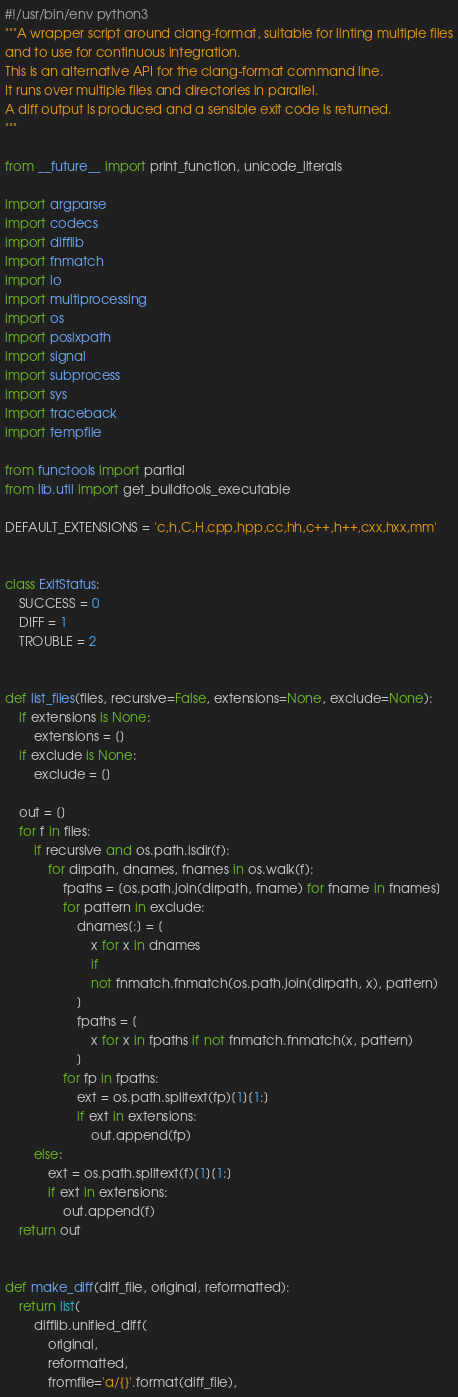Convert code to text. <code><loc_0><loc_0><loc_500><loc_500><_Python_>#!/usr/bin/env python3
"""A wrapper script around clang-format, suitable for linting multiple files
and to use for continuous integration.
This is an alternative API for the clang-format command line.
It runs over multiple files and directories in parallel.
A diff output is produced and a sensible exit code is returned.
"""

from __future__ import print_function, unicode_literals

import argparse
import codecs
import difflib
import fnmatch
import io
import multiprocessing
import os
import posixpath
import signal
import subprocess
import sys
import traceback
import tempfile

from functools import partial
from lib.util import get_buildtools_executable

DEFAULT_EXTENSIONS = 'c,h,C,H,cpp,hpp,cc,hh,c++,h++,cxx,hxx,mm'


class ExitStatus:
    SUCCESS = 0
    DIFF = 1
    TROUBLE = 2


def list_files(files, recursive=False, extensions=None, exclude=None):
    if extensions is None:
        extensions = []
    if exclude is None:
        exclude = []

    out = []
    for f in files:
        if recursive and os.path.isdir(f):
            for dirpath, dnames, fnames in os.walk(f):
                fpaths = [os.path.join(dirpath, fname) for fname in fnames]
                for pattern in exclude:
                    dnames[:] = [
                        x for x in dnames
                        if
                        not fnmatch.fnmatch(os.path.join(dirpath, x), pattern)
                    ]
                    fpaths = [
                        x for x in fpaths if not fnmatch.fnmatch(x, pattern)
                    ]
                for fp in fpaths:
                    ext = os.path.splitext(fp)[1][1:]
                    if ext in extensions:
                        out.append(fp)
        else:
            ext = os.path.splitext(f)[1][1:]
            if ext in extensions:
                out.append(f)
    return out


def make_diff(diff_file, original, reformatted):
    return list(
        difflib.unified_diff(
            original,
            reformatted,
            fromfile='a/{}'.format(diff_file),</code> 